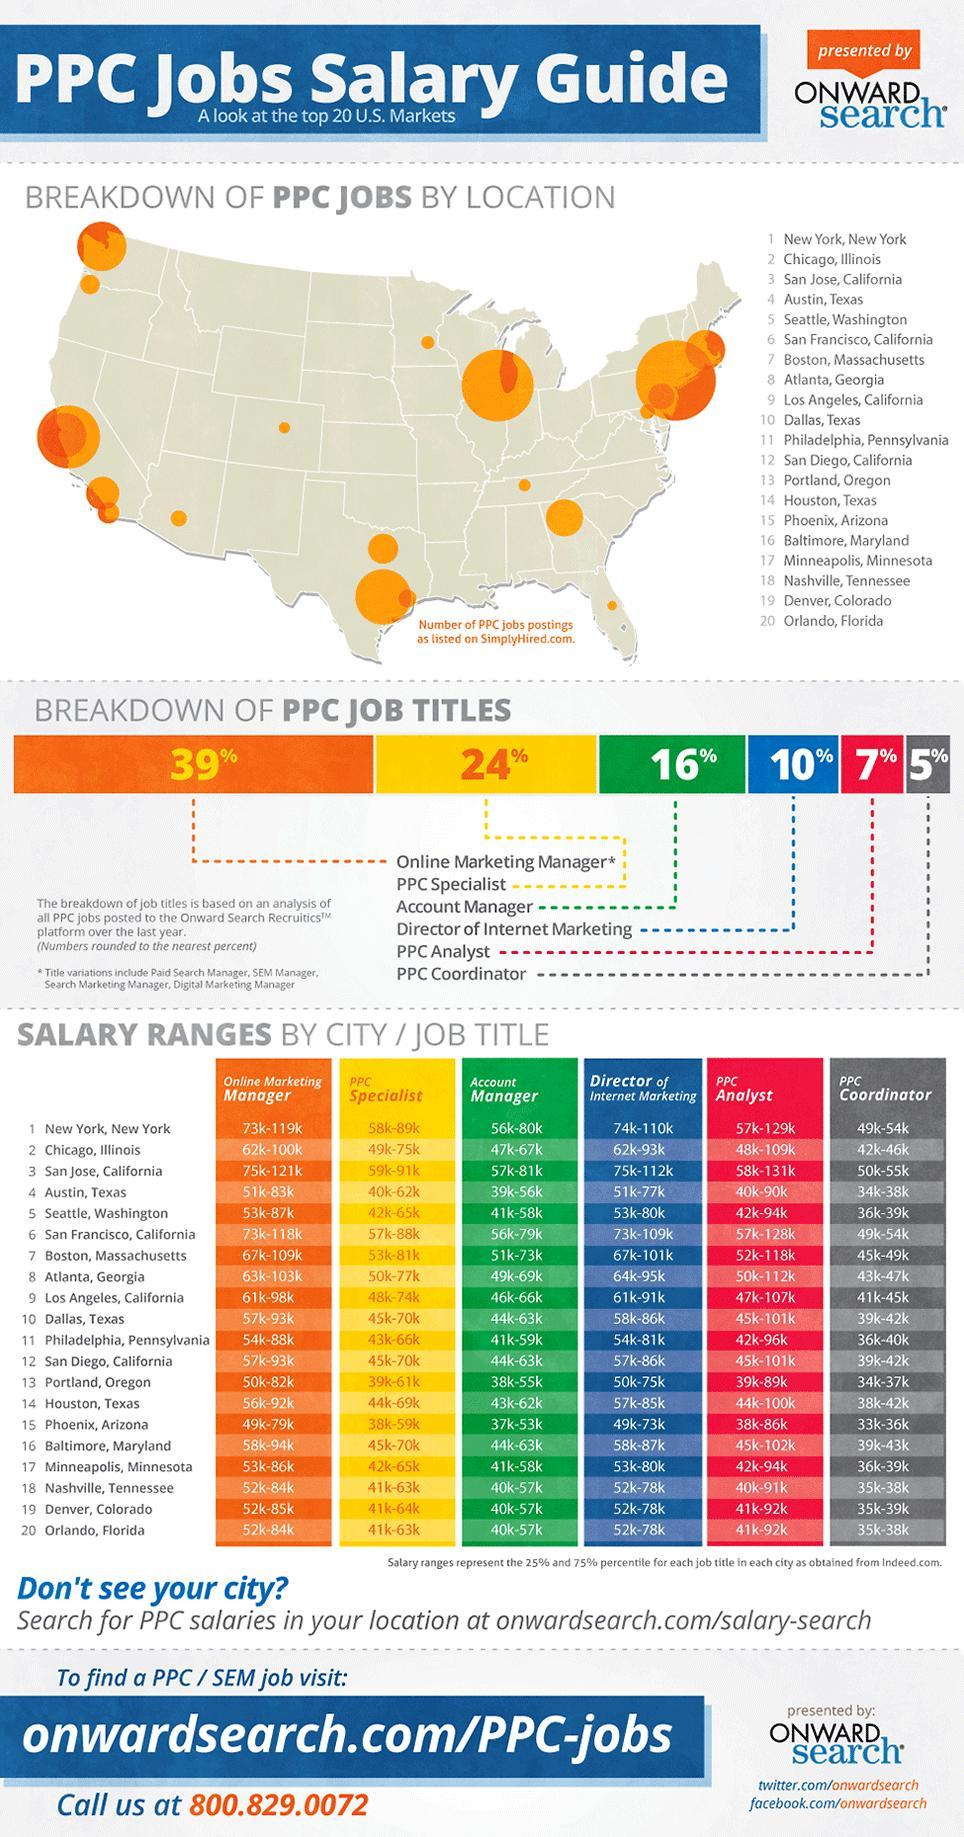What is the total percentage breakdown of all PPC job titles except PPC analyst?
Answer the question with a short phrase. 94% What is the total percentage breakdown of all PPC job titles except PPC specialist? 77% What is the total percentage breakdown of all PPC job titles except the account manager? 85% 